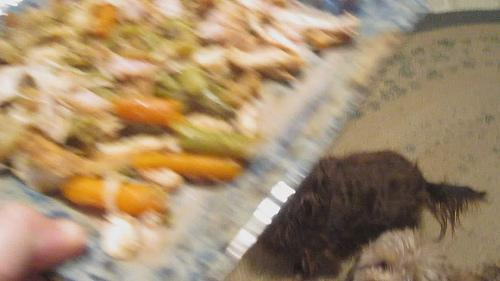Question: who is present?
Choices:
A. Players.
B. Nobody.
C. Crowd.
D. Children.
Answer with the letter. Answer: B 